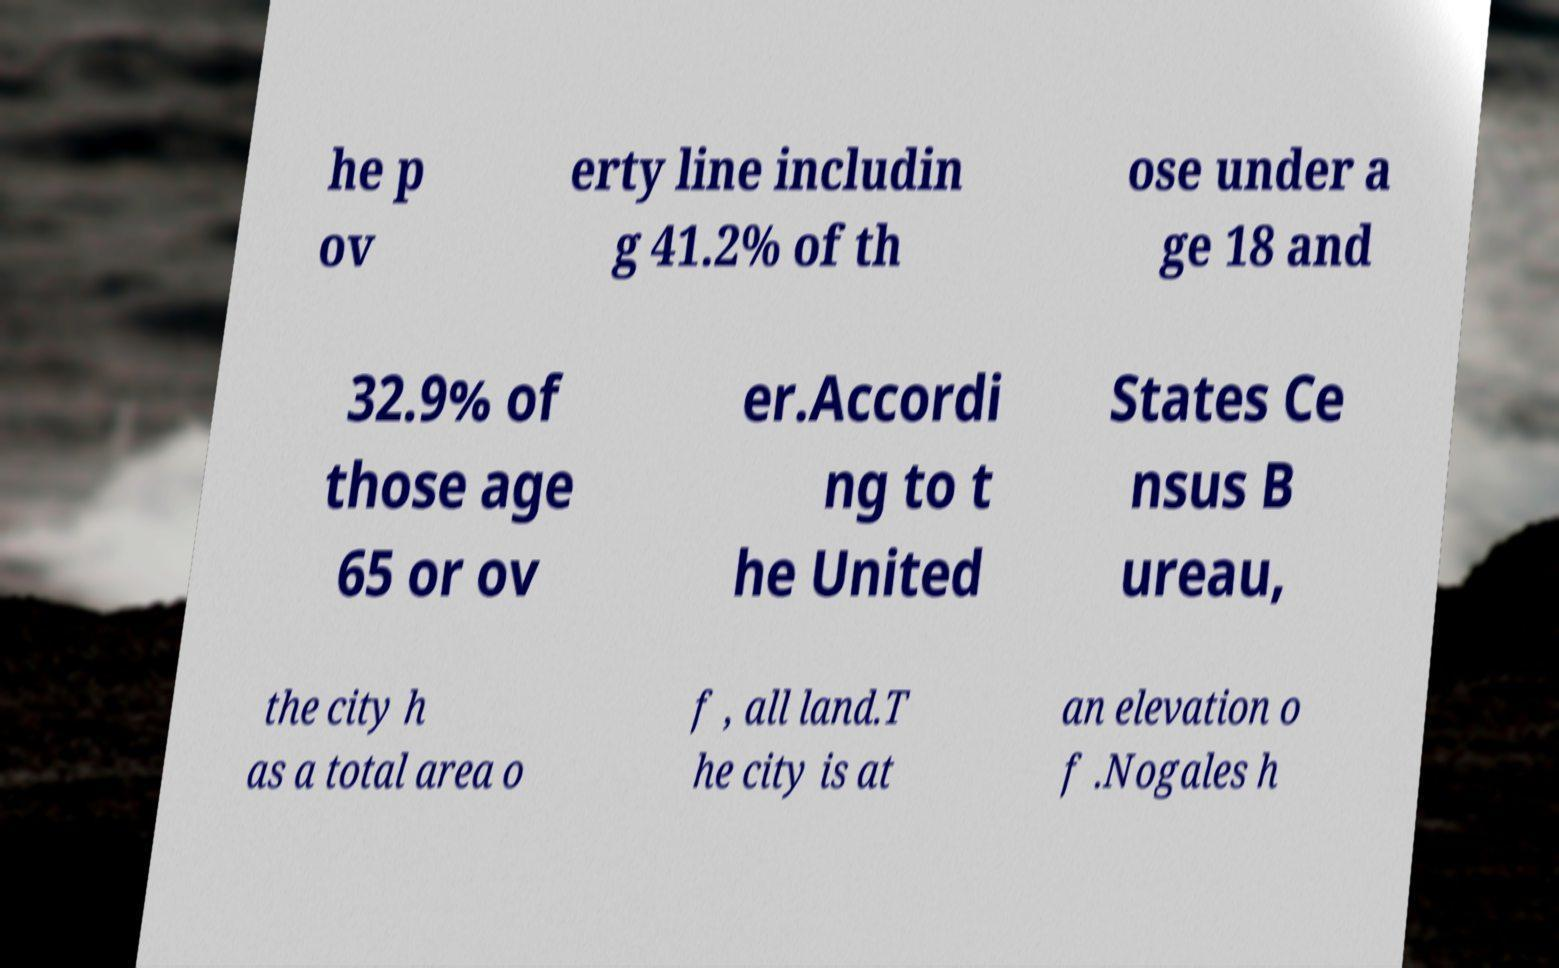Could you assist in decoding the text presented in this image and type it out clearly? he p ov erty line includin g 41.2% of th ose under a ge 18 and 32.9% of those age 65 or ov er.Accordi ng to t he United States Ce nsus B ureau, the city h as a total area o f , all land.T he city is at an elevation o f .Nogales h 